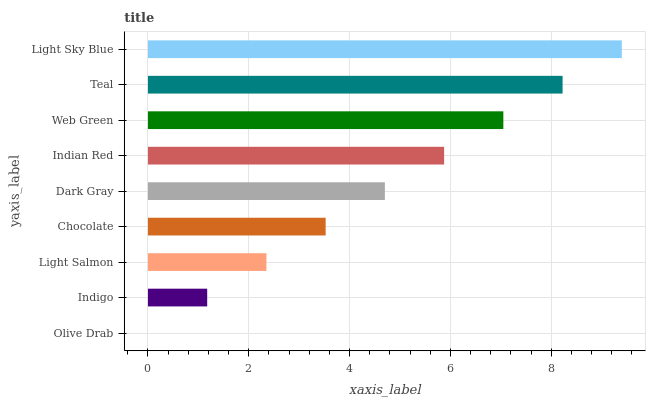Is Olive Drab the minimum?
Answer yes or no. Yes. Is Light Sky Blue the maximum?
Answer yes or no. Yes. Is Indigo the minimum?
Answer yes or no. No. Is Indigo the maximum?
Answer yes or no. No. Is Indigo greater than Olive Drab?
Answer yes or no. Yes. Is Olive Drab less than Indigo?
Answer yes or no. Yes. Is Olive Drab greater than Indigo?
Answer yes or no. No. Is Indigo less than Olive Drab?
Answer yes or no. No. Is Dark Gray the high median?
Answer yes or no. Yes. Is Dark Gray the low median?
Answer yes or no. Yes. Is Indian Red the high median?
Answer yes or no. No. Is Olive Drab the low median?
Answer yes or no. No. 